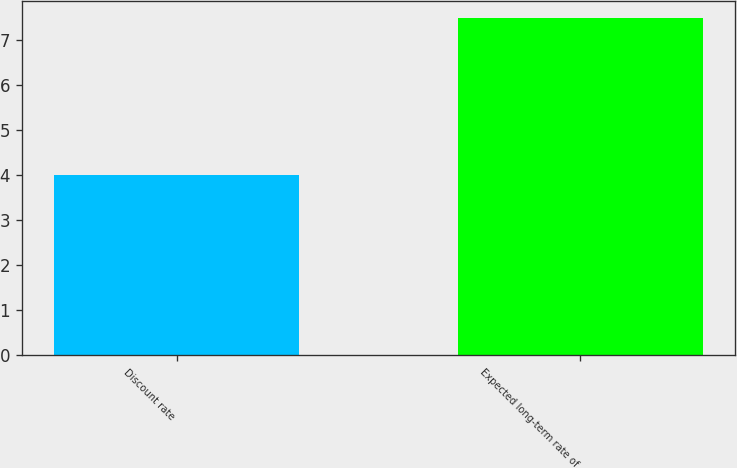Convert chart to OTSL. <chart><loc_0><loc_0><loc_500><loc_500><bar_chart><fcel>Discount rate<fcel>Expected long-term rate of<nl><fcel>4<fcel>7.5<nl></chart> 